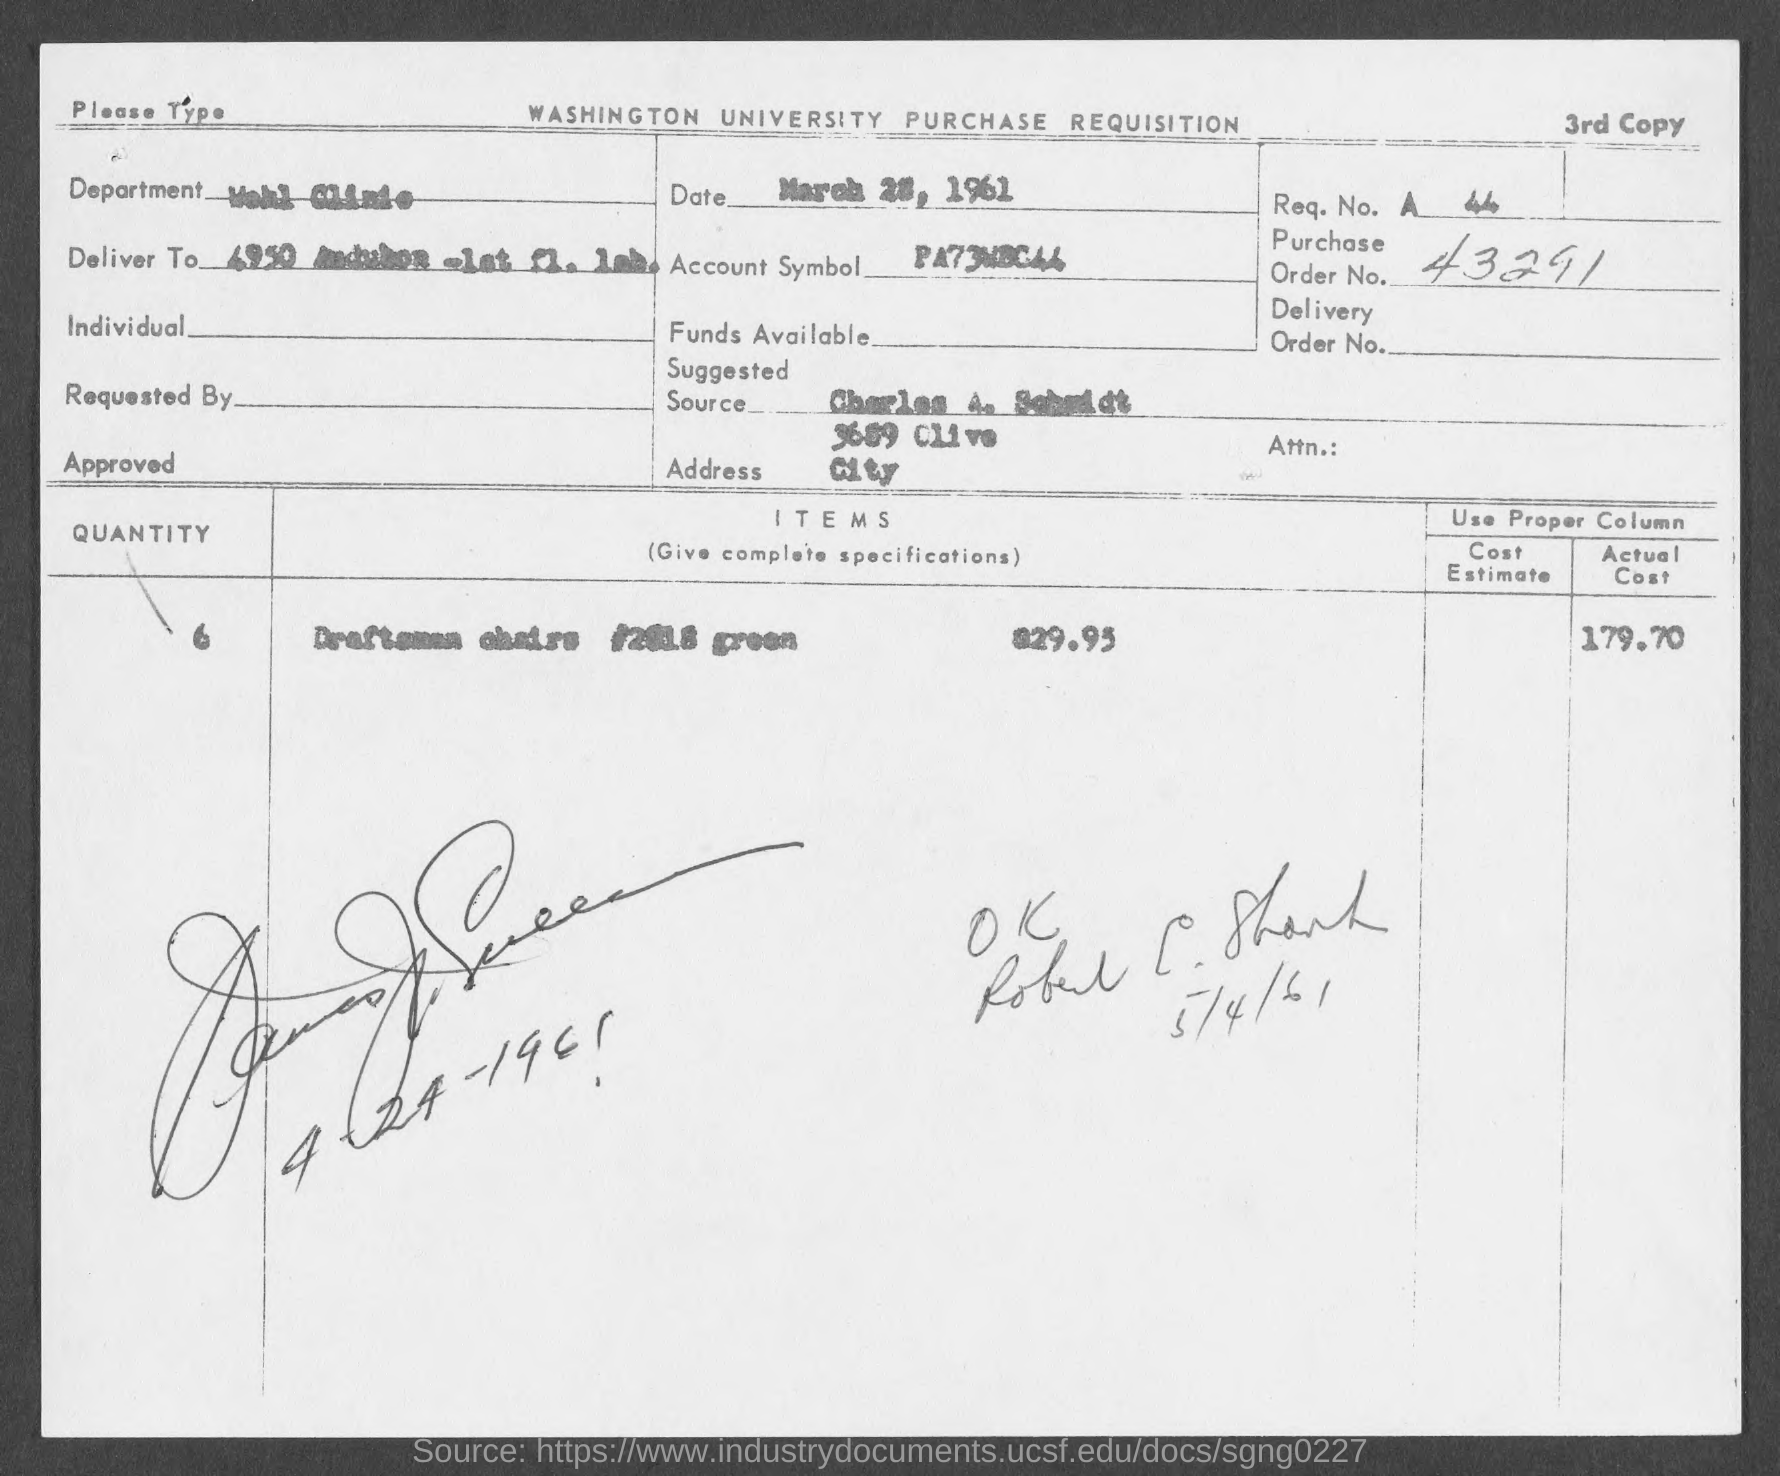Specify some key components in this picture. The question is asking for the number of a purchase order, and it is being provided as "43291... 